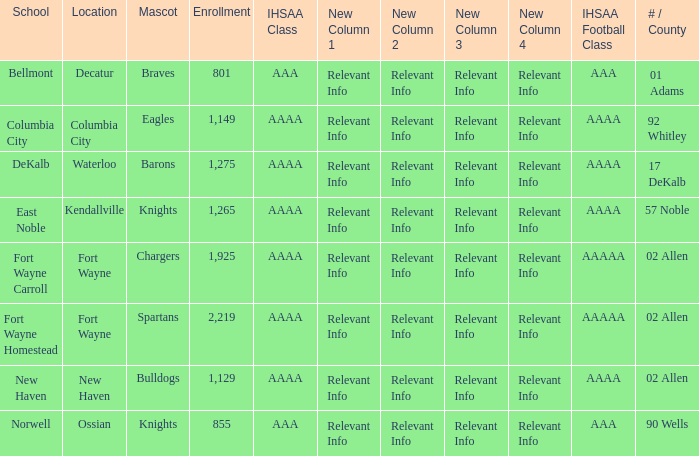What's the IHSAA Football Class in Decatur with an AAA IHSAA class? AAA. Give me the full table as a dictionary. {'header': ['School', 'Location', 'Mascot', 'Enrollment', 'IHSAA Class', 'New Column 1', 'New Column 2', 'New Column 3', 'New Column 4', 'IHSAA Football Class', '# / County'], 'rows': [['Bellmont', 'Decatur', 'Braves', '801', 'AAA', 'Relevant Info', 'Relevant Info', 'Relevant Info', 'Relevant Info', 'AAA', '01 Adams'], ['Columbia City', 'Columbia City', 'Eagles', '1,149', 'AAAA', 'Relevant Info', 'Relevant Info', 'Relevant Info', 'Relevant Info', 'AAAA', '92 Whitley'], ['DeKalb', 'Waterloo', 'Barons', '1,275', 'AAAA', 'Relevant Info', 'Relevant Info', 'Relevant Info', 'Relevant Info', 'AAAA', '17 DeKalb'], ['East Noble', 'Kendallville', 'Knights', '1,265', 'AAAA', 'Relevant Info', 'Relevant Info', 'Relevant Info', 'Relevant Info', 'AAAA', '57 Noble'], ['Fort Wayne Carroll', 'Fort Wayne', 'Chargers', '1,925', 'AAAA', 'Relevant Info', 'Relevant Info', 'Relevant Info', 'Relevant Info', 'AAAAA', '02 Allen'], ['Fort Wayne Homestead', 'Fort Wayne', 'Spartans', '2,219', 'AAAA', 'Relevant Info', 'Relevant Info', 'Relevant Info', 'Relevant Info', 'AAAAA', '02 Allen'], ['New Haven', 'New Haven', 'Bulldogs', '1,129', 'AAAA', 'Relevant Info', 'Relevant Info', 'Relevant Info', 'Relevant Info', 'AAAA', '02 Allen'], ['Norwell', 'Ossian', 'Knights', '855', 'AAA', 'Relevant Info', 'Relevant Info', 'Relevant Info', 'Relevant Info', 'AAA', '90 Wells']]} 